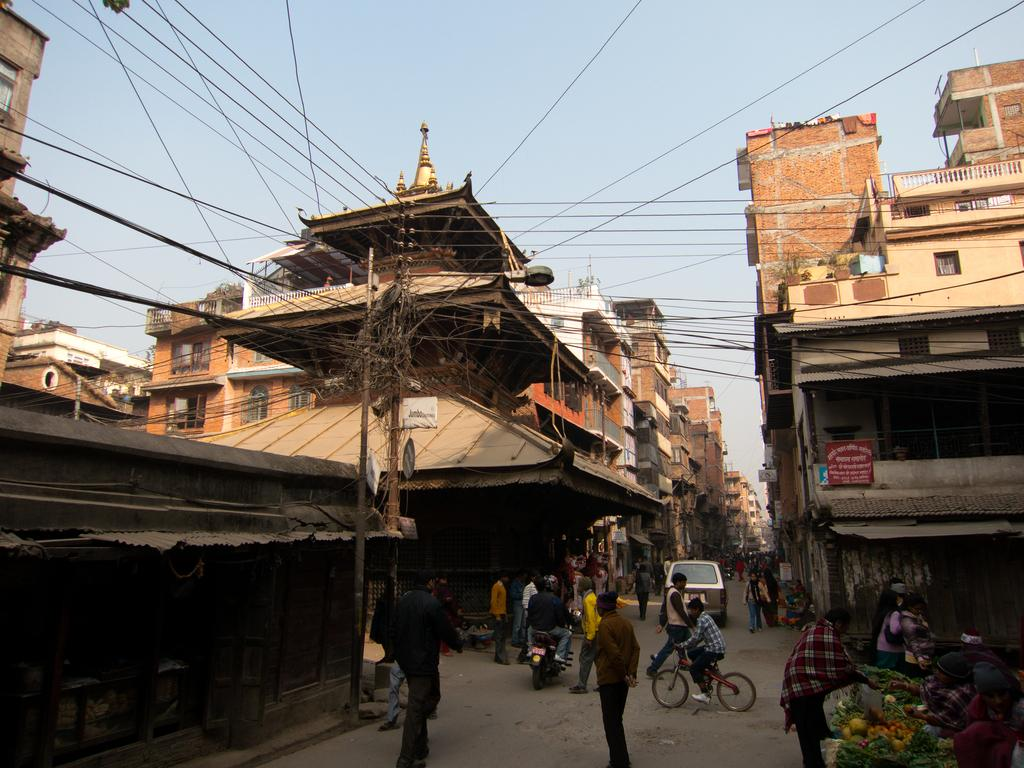What is happening at the bottom of the image? There are people moving on the road at the bottom of the image. What type of structures can be seen in the image? There are buildings in the image. What is located in the middle of the image? There is an electric pole with cables in the middle of the image. What is visible at the top of the image? The sky is visible at the top of the image. Can you tell me which expert is adjusting the comparison in the image? There is no expert or comparison present in the image. The image features people moving on the road, buildings, an electric pole with cables, and the sky. 